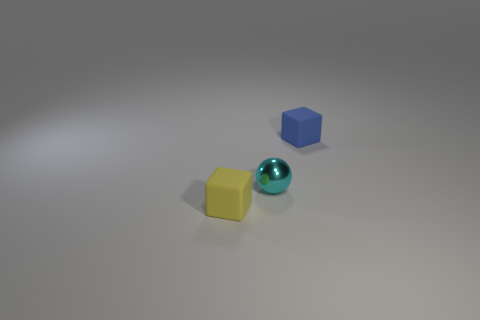Add 2 small cyan balls. How many objects exist? 5 Subtract all cubes. How many objects are left? 1 Subtract all small yellow things. Subtract all cyan metallic things. How many objects are left? 1 Add 2 cyan shiny things. How many cyan shiny things are left? 3 Add 3 tiny cyan metal spheres. How many tiny cyan metal spheres exist? 4 Subtract 0 brown balls. How many objects are left? 3 